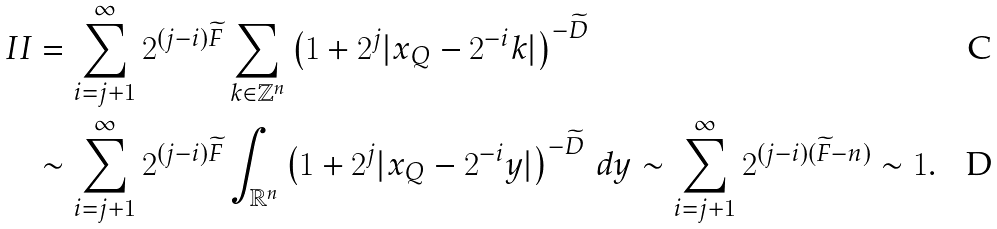<formula> <loc_0><loc_0><loc_500><loc_500>I I & = \sum _ { i = j + 1 } ^ { \infty } 2 ^ { ( j - i ) \widetilde { F } } \sum _ { k \in \mathbb { Z } ^ { n } } \left ( 1 + 2 ^ { j } | x _ { Q } - 2 ^ { - i } k | \right ) ^ { - \widetilde { D } } \\ & \sim \sum _ { i = j + 1 } ^ { \infty } 2 ^ { ( j - i ) \widetilde { F } } \int _ { \mathbb { R } ^ { n } } \left ( 1 + 2 ^ { j } | x _ { Q } - 2 ^ { - i } y | \right ) ^ { - \widetilde { D } } \, d y \sim \sum _ { i = j + 1 } ^ { \infty } 2 ^ { ( j - i ) ( \widetilde { F } - n ) } \sim 1 .</formula> 